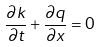Convert formula to latex. <formula><loc_0><loc_0><loc_500><loc_500>\frac { \partial k } { \partial t } + \frac { \partial q } { \partial x } = 0</formula> 